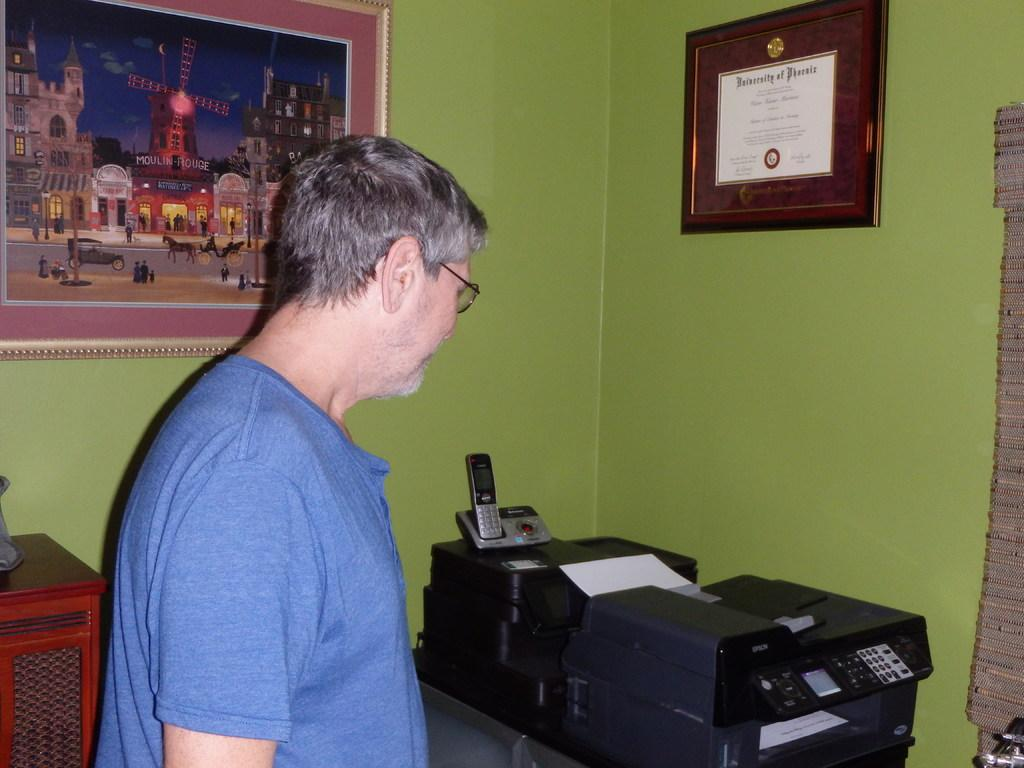Provide a one-sentence caption for the provided image. A man stands in front of an Epson printer and their is a degree from the University of Phoenix framed on the wall. 